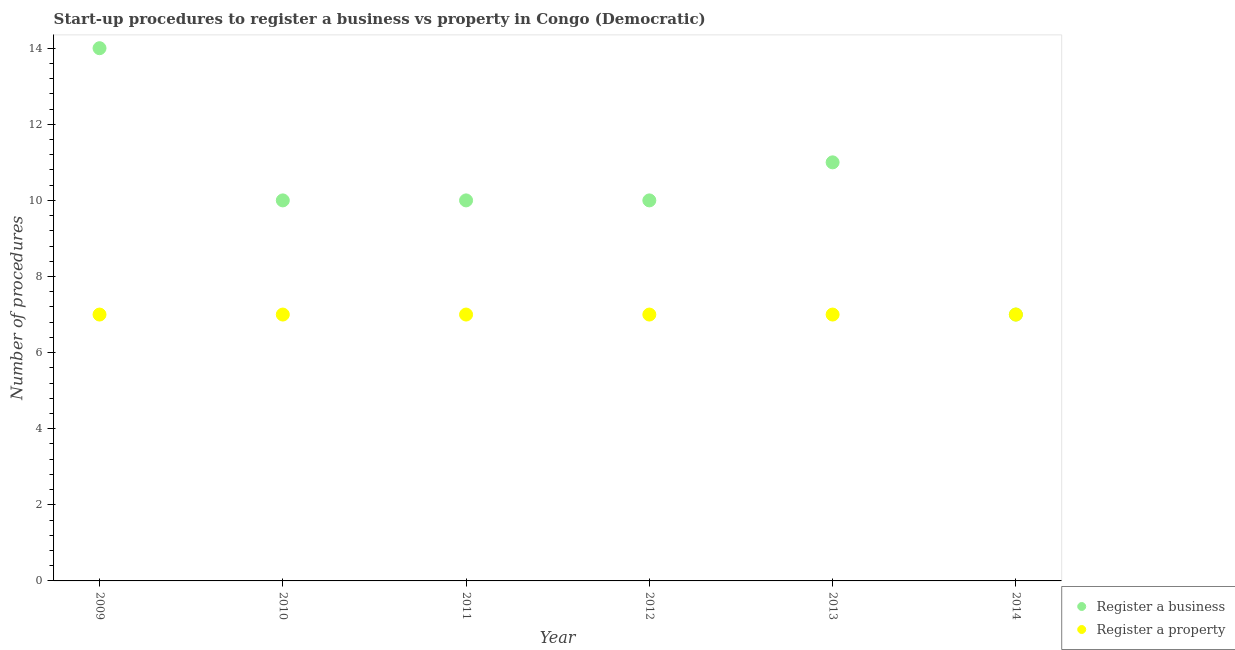How many different coloured dotlines are there?
Your answer should be compact. 2. What is the number of procedures to register a business in 2009?
Give a very brief answer. 14. Across all years, what is the maximum number of procedures to register a property?
Offer a very short reply. 7. Across all years, what is the minimum number of procedures to register a property?
Offer a terse response. 7. What is the total number of procedures to register a property in the graph?
Your answer should be very brief. 42. What is the difference between the number of procedures to register a property in 2010 and the number of procedures to register a business in 2009?
Your answer should be very brief. -7. What is the average number of procedures to register a business per year?
Your response must be concise. 10.33. In the year 2011, what is the difference between the number of procedures to register a business and number of procedures to register a property?
Your answer should be very brief. 3. What is the ratio of the number of procedures to register a business in 2010 to that in 2013?
Keep it short and to the point. 0.91. Is the difference between the number of procedures to register a business in 2009 and 2012 greater than the difference between the number of procedures to register a property in 2009 and 2012?
Ensure brevity in your answer.  Yes. Does the number of procedures to register a business monotonically increase over the years?
Your answer should be very brief. No. Is the number of procedures to register a property strictly greater than the number of procedures to register a business over the years?
Provide a short and direct response. No. Is the number of procedures to register a property strictly less than the number of procedures to register a business over the years?
Give a very brief answer. No. How many dotlines are there?
Offer a very short reply. 2. How many years are there in the graph?
Provide a short and direct response. 6. Does the graph contain grids?
Your answer should be very brief. No. Where does the legend appear in the graph?
Offer a terse response. Bottom right. What is the title of the graph?
Your response must be concise. Start-up procedures to register a business vs property in Congo (Democratic). What is the label or title of the Y-axis?
Provide a short and direct response. Number of procedures. What is the Number of procedures of Register a business in 2009?
Make the answer very short. 14. What is the Number of procedures in Register a business in 2010?
Keep it short and to the point. 10. What is the Number of procedures in Register a property in 2010?
Your answer should be very brief. 7. What is the Number of procedures in Register a property in 2011?
Your response must be concise. 7. Across all years, what is the minimum Number of procedures in Register a business?
Provide a short and direct response. 7. Across all years, what is the minimum Number of procedures in Register a property?
Offer a very short reply. 7. What is the difference between the Number of procedures of Register a business in 2009 and that in 2011?
Provide a short and direct response. 4. What is the difference between the Number of procedures of Register a property in 2009 and that in 2011?
Keep it short and to the point. 0. What is the difference between the Number of procedures of Register a property in 2009 and that in 2012?
Make the answer very short. 0. What is the difference between the Number of procedures in Register a property in 2009 and that in 2013?
Your response must be concise. 0. What is the difference between the Number of procedures of Register a property in 2010 and that in 2011?
Make the answer very short. 0. What is the difference between the Number of procedures of Register a property in 2010 and that in 2012?
Ensure brevity in your answer.  0. What is the difference between the Number of procedures of Register a business in 2010 and that in 2013?
Your answer should be compact. -1. What is the difference between the Number of procedures of Register a business in 2011 and that in 2012?
Your answer should be compact. 0. What is the difference between the Number of procedures of Register a property in 2011 and that in 2013?
Your answer should be very brief. 0. What is the difference between the Number of procedures in Register a property in 2011 and that in 2014?
Your answer should be compact. 0. What is the difference between the Number of procedures in Register a property in 2012 and that in 2013?
Offer a terse response. 0. What is the difference between the Number of procedures in Register a business in 2012 and that in 2014?
Provide a short and direct response. 3. What is the difference between the Number of procedures of Register a property in 2012 and that in 2014?
Ensure brevity in your answer.  0. What is the difference between the Number of procedures in Register a business in 2013 and that in 2014?
Your answer should be compact. 4. What is the difference between the Number of procedures of Register a business in 2009 and the Number of procedures of Register a property in 2011?
Your answer should be very brief. 7. What is the difference between the Number of procedures of Register a business in 2009 and the Number of procedures of Register a property in 2014?
Make the answer very short. 7. What is the difference between the Number of procedures of Register a business in 2010 and the Number of procedures of Register a property in 2011?
Give a very brief answer. 3. What is the difference between the Number of procedures in Register a business in 2011 and the Number of procedures in Register a property in 2014?
Keep it short and to the point. 3. What is the difference between the Number of procedures of Register a business in 2012 and the Number of procedures of Register a property in 2014?
Your response must be concise. 3. What is the average Number of procedures in Register a business per year?
Give a very brief answer. 10.33. In the year 2009, what is the difference between the Number of procedures of Register a business and Number of procedures of Register a property?
Your response must be concise. 7. In the year 2010, what is the difference between the Number of procedures in Register a business and Number of procedures in Register a property?
Provide a short and direct response. 3. In the year 2011, what is the difference between the Number of procedures in Register a business and Number of procedures in Register a property?
Offer a very short reply. 3. In the year 2013, what is the difference between the Number of procedures of Register a business and Number of procedures of Register a property?
Provide a short and direct response. 4. In the year 2014, what is the difference between the Number of procedures of Register a business and Number of procedures of Register a property?
Offer a terse response. 0. What is the ratio of the Number of procedures of Register a business in 2009 to that in 2010?
Provide a succinct answer. 1.4. What is the ratio of the Number of procedures of Register a property in 2009 to that in 2010?
Offer a very short reply. 1. What is the ratio of the Number of procedures in Register a property in 2009 to that in 2011?
Provide a short and direct response. 1. What is the ratio of the Number of procedures of Register a business in 2009 to that in 2013?
Make the answer very short. 1.27. What is the ratio of the Number of procedures of Register a property in 2009 to that in 2013?
Give a very brief answer. 1. What is the ratio of the Number of procedures in Register a business in 2009 to that in 2014?
Provide a short and direct response. 2. What is the ratio of the Number of procedures in Register a property in 2010 to that in 2011?
Provide a short and direct response. 1. What is the ratio of the Number of procedures in Register a business in 2010 to that in 2012?
Your response must be concise. 1. What is the ratio of the Number of procedures of Register a property in 2010 to that in 2012?
Offer a terse response. 1. What is the ratio of the Number of procedures in Register a business in 2010 to that in 2014?
Your answer should be very brief. 1.43. What is the ratio of the Number of procedures of Register a property in 2010 to that in 2014?
Provide a short and direct response. 1. What is the ratio of the Number of procedures of Register a property in 2011 to that in 2012?
Your answer should be compact. 1. What is the ratio of the Number of procedures of Register a property in 2011 to that in 2013?
Give a very brief answer. 1. What is the ratio of the Number of procedures in Register a business in 2011 to that in 2014?
Your answer should be compact. 1.43. What is the ratio of the Number of procedures of Register a property in 2011 to that in 2014?
Give a very brief answer. 1. What is the ratio of the Number of procedures of Register a business in 2012 to that in 2013?
Your answer should be compact. 0.91. What is the ratio of the Number of procedures in Register a property in 2012 to that in 2013?
Your answer should be very brief. 1. What is the ratio of the Number of procedures of Register a business in 2012 to that in 2014?
Provide a short and direct response. 1.43. What is the ratio of the Number of procedures in Register a property in 2012 to that in 2014?
Provide a succinct answer. 1. What is the ratio of the Number of procedures in Register a business in 2013 to that in 2014?
Provide a succinct answer. 1.57. What is the ratio of the Number of procedures in Register a property in 2013 to that in 2014?
Keep it short and to the point. 1. What is the difference between the highest and the lowest Number of procedures of Register a business?
Offer a terse response. 7. What is the difference between the highest and the lowest Number of procedures of Register a property?
Provide a short and direct response. 0. 